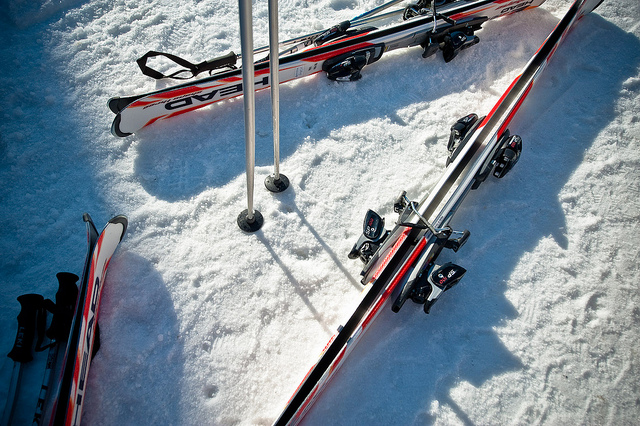Identify the text contained in this image. HEAD 